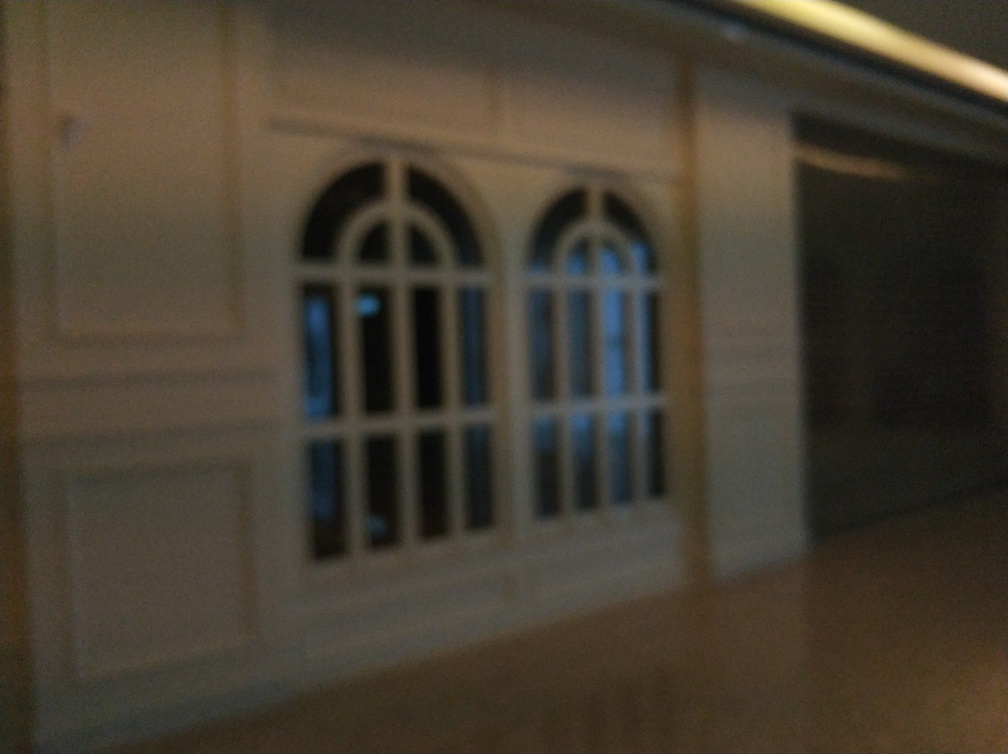How would you describe the quality of this image? Given the blurriness and lack of sharpness in the image, it is difficult to discern fine details, which suggests the quality is below average. Factors that may have affected the image quality include low lighting conditions, camera shake, or an out-of-focus lens. To improve the quality, one might consider using a tripod, better lighting, or adjusting the camera's focus settings. 